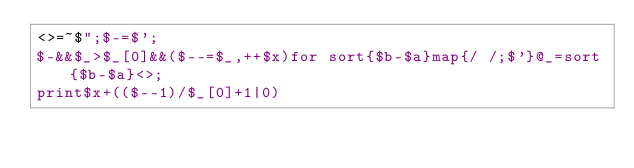Convert code to text. <code><loc_0><loc_0><loc_500><loc_500><_Perl_><>=~$";$-=$';
$-&&$_>$_[0]&&($--=$_,++$x)for sort{$b-$a}map{/ /;$'}@_=sort{$b-$a}<>;
print$x+(($--1)/$_[0]+1|0)
</code> 